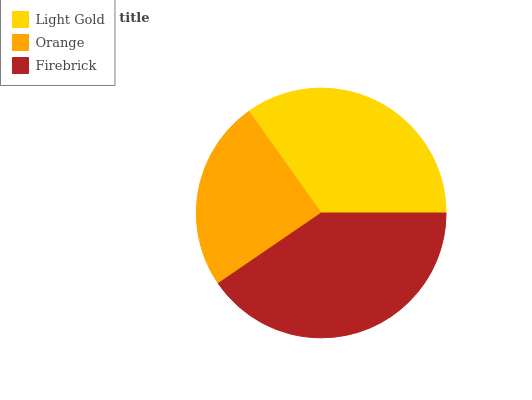Is Orange the minimum?
Answer yes or no. Yes. Is Firebrick the maximum?
Answer yes or no. Yes. Is Firebrick the minimum?
Answer yes or no. No. Is Orange the maximum?
Answer yes or no. No. Is Firebrick greater than Orange?
Answer yes or no. Yes. Is Orange less than Firebrick?
Answer yes or no. Yes. Is Orange greater than Firebrick?
Answer yes or no. No. Is Firebrick less than Orange?
Answer yes or no. No. Is Light Gold the high median?
Answer yes or no. Yes. Is Light Gold the low median?
Answer yes or no. Yes. Is Firebrick the high median?
Answer yes or no. No. Is Firebrick the low median?
Answer yes or no. No. 